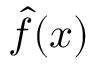<formula> <loc_0><loc_0><loc_500><loc_500>\hat { f } ( x )</formula> 